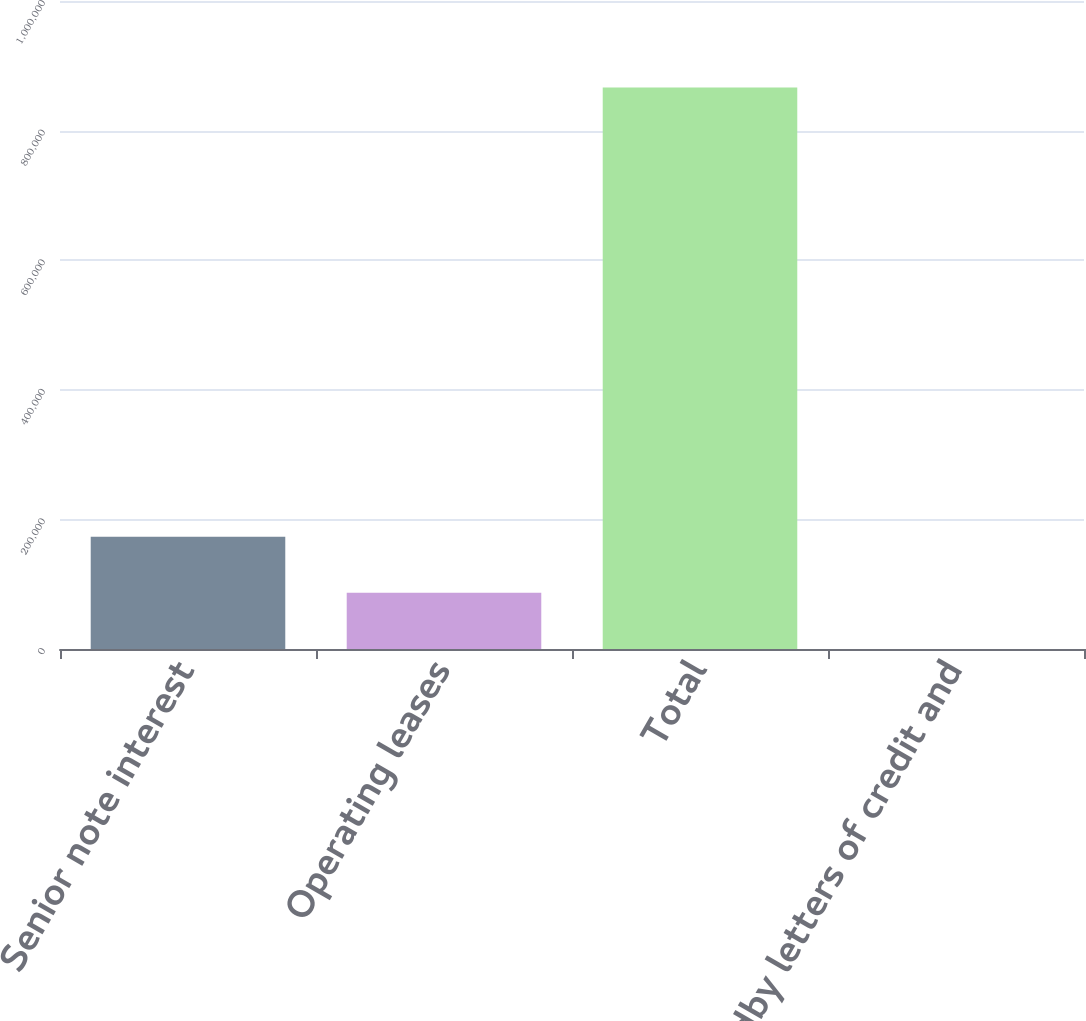Convert chart to OTSL. <chart><loc_0><loc_0><loc_500><loc_500><bar_chart><fcel>Senior note interest<fcel>Operating leases<fcel>Total<fcel>Standby letters of credit and<nl><fcel>173368<fcel>86740.3<fcel>866386<fcel>113<nl></chart> 